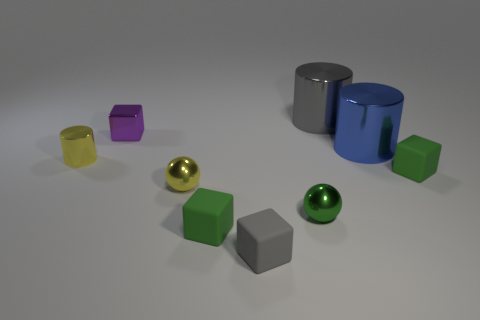What material is the yellow sphere that is behind the green shiny thing?
Your response must be concise. Metal. There is a tiny ball that is on the left side of the small green sphere; does it have the same color as the cylinder that is left of the gray metallic cylinder?
Give a very brief answer. Yes. Is there a small ball of the same color as the tiny shiny cylinder?
Your response must be concise. Yes. There is a big blue metallic object; what shape is it?
Provide a succinct answer. Cylinder. What number of gray objects are big rubber cubes or tiny matte cubes?
Provide a short and direct response. 1. Is the number of large gray metal cylinders greater than the number of gray rubber cylinders?
Give a very brief answer. Yes. What number of objects are either matte cubes that are behind the tiny gray block or small things that are behind the small gray matte cube?
Provide a succinct answer. 6. There is a metal cube that is the same size as the green ball; what color is it?
Provide a succinct answer. Purple. Is the small purple thing made of the same material as the green ball?
Your answer should be very brief. Yes. What is the material of the thing that is behind the tiny block behind the small metallic cylinder?
Keep it short and to the point. Metal. 